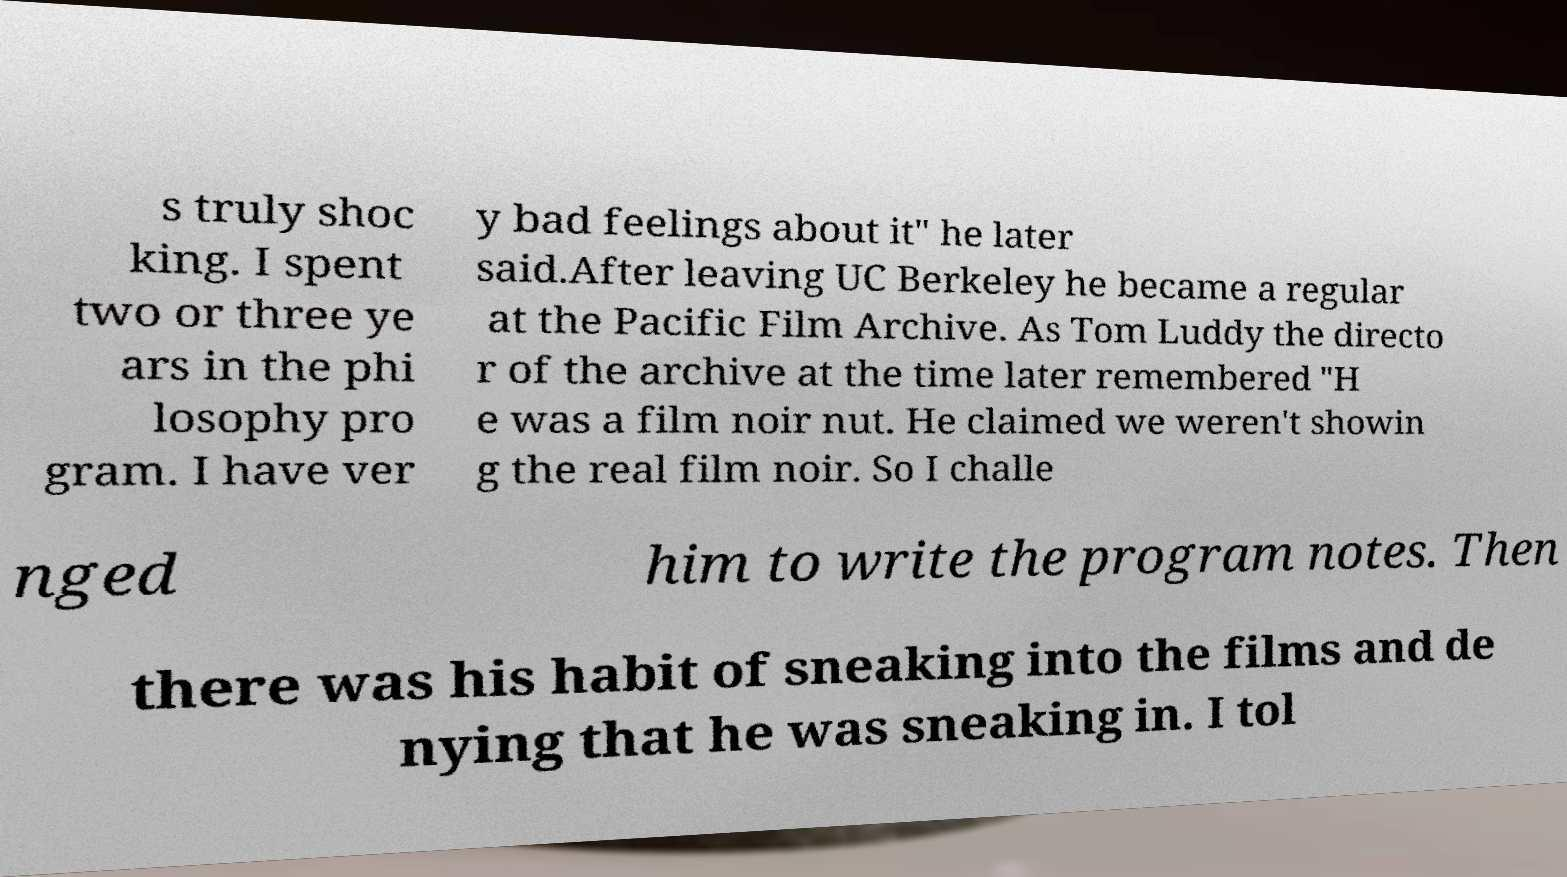For documentation purposes, I need the text within this image transcribed. Could you provide that? s truly shoc king. I spent two or three ye ars in the phi losophy pro gram. I have ver y bad feelings about it" he later said.After leaving UC Berkeley he became a regular at the Pacific Film Archive. As Tom Luddy the directo r of the archive at the time later remembered "H e was a film noir nut. He claimed we weren't showin g the real film noir. So I challe nged him to write the program notes. Then there was his habit of sneaking into the films and de nying that he was sneaking in. I tol 